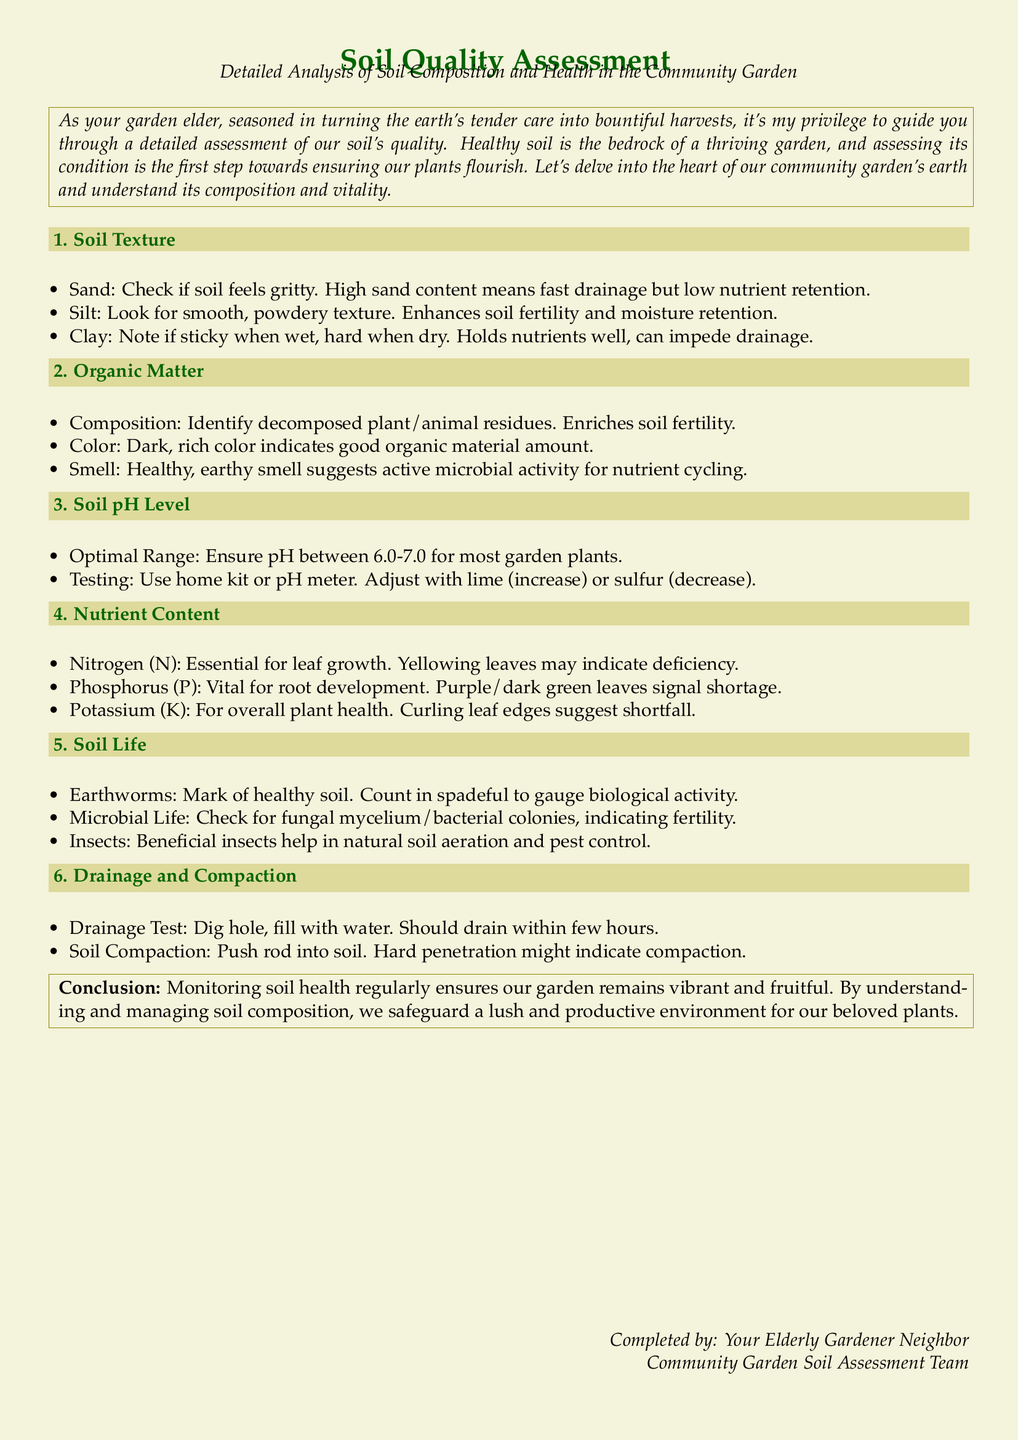What is the optimal pH range for most garden plants? The document states that the optimal pH range is between 6.0-7.0 for most garden plants.
Answer: 6.0-7.0 Which soil texture indicates good nutrient retention? The document explains that clay soil holds nutrients well.
Answer: Clay What indicates a high nitrogen deficiency in plants? The document mentions that yellowing leaves may indicate nitrogen deficiency.
Answer: Yellowing leaves What should be done to increase soil pH? The document indicates that lime is used to increase soil pH.
Answer: Lime What is a sign of healthy soil in terms of earthworms? The document states that earthworms are a mark of healthy soil.
Answer: Earthworms How should drainage be tested according to the document? The document describes that the drainage test involves digging a hole and filling it with water to observe how fast it drains.
Answer: Dig hole, fill with water What does a dark, rich color in soil suggest? The document specifies that a dark, rich color indicates a good amount of organic material.
Answer: Good organic material amount What is the primary role of phosphorus in soil? The document indicates that phosphorus is vital for root development.
Answer: Root development How can soil compaction be tested? The document mentions pushing a rod into the soil to check for hardness as a test for compaction.
Answer: Push rod into soil 